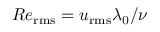Convert formula to latex. <formula><loc_0><loc_0><loc_500><loc_500>R e _ { r m s } = u _ { r m s } \lambda _ { 0 } / \nu</formula> 